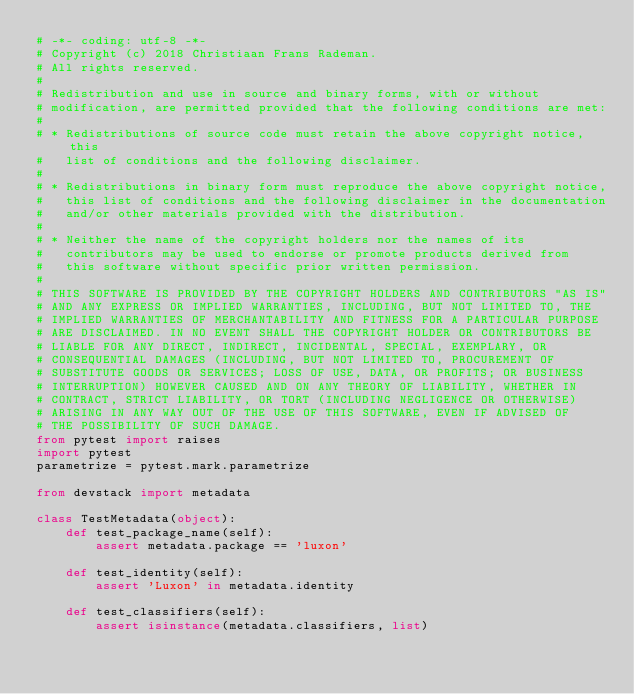<code> <loc_0><loc_0><loc_500><loc_500><_Python_># -*- coding: utf-8 -*-
# Copyright (c) 2018 Christiaan Frans Rademan.
# All rights reserved.
#
# Redistribution and use in source and binary forms, with or without
# modification, are permitted provided that the following conditions are met:
#
# * Redistributions of source code must retain the above copyright notice, this
#   list of conditions and the following disclaimer.
#
# * Redistributions in binary form must reproduce the above copyright notice,
#   this list of conditions and the following disclaimer in the documentation
#   and/or other materials provided with the distribution.
#
# * Neither the name of the copyright holders nor the names of its
#   contributors may be used to endorse or promote products derived from
#   this software without specific prior written permission.
#
# THIS SOFTWARE IS PROVIDED BY THE COPYRIGHT HOLDERS AND CONTRIBUTORS "AS IS"
# AND ANY EXPRESS OR IMPLIED WARRANTIES, INCLUDING, BUT NOT LIMITED TO, THE
# IMPLIED WARRANTIES OF MERCHANTABILITY AND FITNESS FOR A PARTICULAR PURPOSE
# ARE DISCLAIMED. IN NO EVENT SHALL THE COPYRIGHT HOLDER OR CONTRIBUTORS BE
# LIABLE FOR ANY DIRECT, INDIRECT, INCIDENTAL, SPECIAL, EXEMPLARY, OR
# CONSEQUENTIAL DAMAGES (INCLUDING, BUT NOT LIMITED TO, PROCUREMENT OF
# SUBSTITUTE GOODS OR SERVICES; LOSS OF USE, DATA, OR PROFITS; OR BUSINESS
# INTERRUPTION) HOWEVER CAUSED AND ON ANY THEORY OF LIABILITY, WHETHER IN
# CONTRACT, STRICT LIABILITY, OR TORT (INCLUDING NEGLIGENCE OR OTHERWISE)
# ARISING IN ANY WAY OUT OF THE USE OF THIS SOFTWARE, EVEN IF ADVISED OF
# THE POSSIBILITY OF SUCH DAMAGE.
from pytest import raises
import pytest
parametrize = pytest.mark.parametrize

from devstack import metadata

class TestMetadata(object):
    def test_package_name(self):
        assert metadata.package == 'luxon'

    def test_identity(self):
        assert 'Luxon' in metadata.identity

    def test_classifiers(self):
        assert isinstance(metadata.classifiers, list)
</code> 